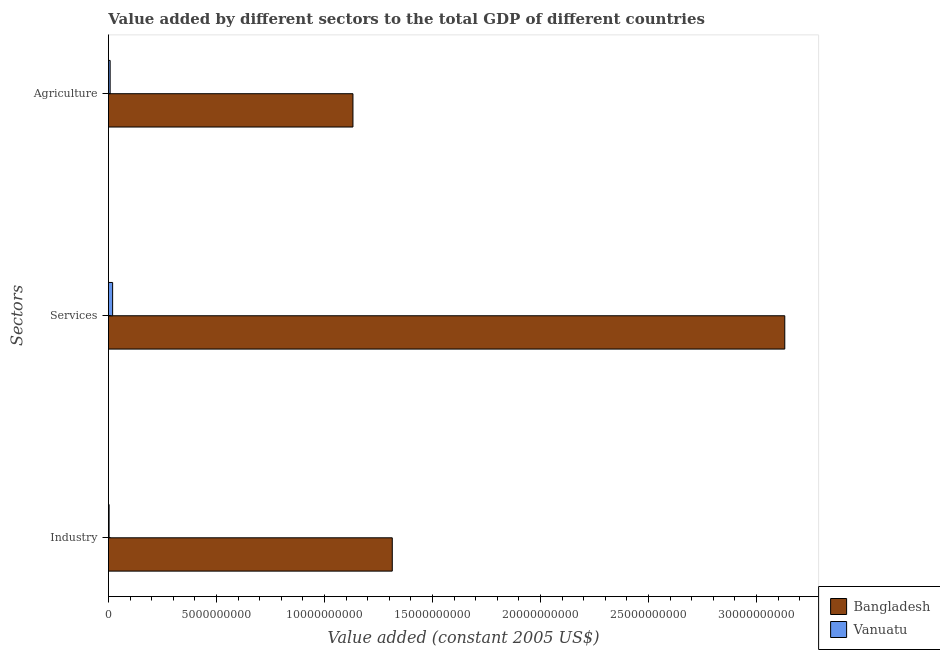How many different coloured bars are there?
Make the answer very short. 2. How many groups of bars are there?
Offer a terse response. 3. Are the number of bars per tick equal to the number of legend labels?
Offer a terse response. Yes. Are the number of bars on each tick of the Y-axis equal?
Ensure brevity in your answer.  Yes. How many bars are there on the 2nd tick from the bottom?
Your response must be concise. 2. What is the label of the 3rd group of bars from the top?
Make the answer very short. Industry. What is the value added by services in Bangladesh?
Provide a succinct answer. 3.13e+1. Across all countries, what is the maximum value added by agricultural sector?
Provide a succinct answer. 1.13e+1. Across all countries, what is the minimum value added by agricultural sector?
Give a very brief answer. 7.93e+07. In which country was the value added by services minimum?
Provide a short and direct response. Vanuatu. What is the total value added by industrial sector in the graph?
Offer a very short reply. 1.32e+1. What is the difference between the value added by industrial sector in Vanuatu and that in Bangladesh?
Offer a very short reply. -1.31e+1. What is the difference between the value added by services in Vanuatu and the value added by industrial sector in Bangladesh?
Provide a short and direct response. -1.29e+1. What is the average value added by industrial sector per country?
Offer a terse response. 6.59e+09. What is the difference between the value added by industrial sector and value added by agricultural sector in Vanuatu?
Your answer should be very brief. -4.77e+07. In how many countries, is the value added by agricultural sector greater than 22000000000 US$?
Your response must be concise. 0. What is the ratio of the value added by services in Vanuatu to that in Bangladesh?
Offer a terse response. 0.01. What is the difference between the highest and the second highest value added by industrial sector?
Make the answer very short. 1.31e+1. What is the difference between the highest and the lowest value added by services?
Make the answer very short. 3.11e+1. In how many countries, is the value added by services greater than the average value added by services taken over all countries?
Ensure brevity in your answer.  1. Is the sum of the value added by industrial sector in Bangladesh and Vanuatu greater than the maximum value added by services across all countries?
Keep it short and to the point. No. What does the 2nd bar from the bottom in Services represents?
Give a very brief answer. Vanuatu. How many bars are there?
Offer a very short reply. 6. What is the difference between two consecutive major ticks on the X-axis?
Give a very brief answer. 5.00e+09. Where does the legend appear in the graph?
Make the answer very short. Bottom right. How many legend labels are there?
Ensure brevity in your answer.  2. How are the legend labels stacked?
Your answer should be compact. Vertical. What is the title of the graph?
Your answer should be very brief. Value added by different sectors to the total GDP of different countries. What is the label or title of the X-axis?
Keep it short and to the point. Value added (constant 2005 US$). What is the label or title of the Y-axis?
Offer a terse response. Sectors. What is the Value added (constant 2005 US$) in Bangladesh in Industry?
Provide a short and direct response. 1.31e+1. What is the Value added (constant 2005 US$) of Vanuatu in Industry?
Your response must be concise. 3.15e+07. What is the Value added (constant 2005 US$) in Bangladesh in Services?
Provide a succinct answer. 3.13e+1. What is the Value added (constant 2005 US$) in Vanuatu in Services?
Your answer should be very brief. 1.94e+08. What is the Value added (constant 2005 US$) of Bangladesh in Agriculture?
Your answer should be compact. 1.13e+1. What is the Value added (constant 2005 US$) in Vanuatu in Agriculture?
Make the answer very short. 7.93e+07. Across all Sectors, what is the maximum Value added (constant 2005 US$) in Bangladesh?
Provide a short and direct response. 3.13e+1. Across all Sectors, what is the maximum Value added (constant 2005 US$) in Vanuatu?
Ensure brevity in your answer.  1.94e+08. Across all Sectors, what is the minimum Value added (constant 2005 US$) in Bangladesh?
Offer a terse response. 1.13e+1. Across all Sectors, what is the minimum Value added (constant 2005 US$) of Vanuatu?
Ensure brevity in your answer.  3.15e+07. What is the total Value added (constant 2005 US$) of Bangladesh in the graph?
Provide a succinct answer. 5.58e+1. What is the total Value added (constant 2005 US$) of Vanuatu in the graph?
Offer a very short reply. 3.05e+08. What is the difference between the Value added (constant 2005 US$) of Bangladesh in Industry and that in Services?
Your answer should be very brief. -1.82e+1. What is the difference between the Value added (constant 2005 US$) in Vanuatu in Industry and that in Services?
Keep it short and to the point. -1.63e+08. What is the difference between the Value added (constant 2005 US$) in Bangladesh in Industry and that in Agriculture?
Your answer should be very brief. 1.82e+09. What is the difference between the Value added (constant 2005 US$) in Vanuatu in Industry and that in Agriculture?
Give a very brief answer. -4.77e+07. What is the difference between the Value added (constant 2005 US$) in Bangladesh in Services and that in Agriculture?
Offer a very short reply. 2.00e+1. What is the difference between the Value added (constant 2005 US$) of Vanuatu in Services and that in Agriculture?
Provide a short and direct response. 1.15e+08. What is the difference between the Value added (constant 2005 US$) in Bangladesh in Industry and the Value added (constant 2005 US$) in Vanuatu in Services?
Your response must be concise. 1.29e+1. What is the difference between the Value added (constant 2005 US$) of Bangladesh in Industry and the Value added (constant 2005 US$) of Vanuatu in Agriculture?
Give a very brief answer. 1.31e+1. What is the difference between the Value added (constant 2005 US$) of Bangladesh in Services and the Value added (constant 2005 US$) of Vanuatu in Agriculture?
Ensure brevity in your answer.  3.12e+1. What is the average Value added (constant 2005 US$) in Bangladesh per Sectors?
Offer a very short reply. 1.86e+1. What is the average Value added (constant 2005 US$) in Vanuatu per Sectors?
Your answer should be very brief. 1.02e+08. What is the difference between the Value added (constant 2005 US$) in Bangladesh and Value added (constant 2005 US$) in Vanuatu in Industry?
Provide a short and direct response. 1.31e+1. What is the difference between the Value added (constant 2005 US$) of Bangladesh and Value added (constant 2005 US$) of Vanuatu in Services?
Offer a very short reply. 3.11e+1. What is the difference between the Value added (constant 2005 US$) of Bangladesh and Value added (constant 2005 US$) of Vanuatu in Agriculture?
Your response must be concise. 1.12e+1. What is the ratio of the Value added (constant 2005 US$) in Bangladesh in Industry to that in Services?
Your response must be concise. 0.42. What is the ratio of the Value added (constant 2005 US$) in Vanuatu in Industry to that in Services?
Offer a terse response. 0.16. What is the ratio of the Value added (constant 2005 US$) in Bangladesh in Industry to that in Agriculture?
Your response must be concise. 1.16. What is the ratio of the Value added (constant 2005 US$) of Vanuatu in Industry to that in Agriculture?
Provide a short and direct response. 0.4. What is the ratio of the Value added (constant 2005 US$) of Bangladesh in Services to that in Agriculture?
Offer a very short reply. 2.77. What is the ratio of the Value added (constant 2005 US$) in Vanuatu in Services to that in Agriculture?
Your answer should be very brief. 2.45. What is the difference between the highest and the second highest Value added (constant 2005 US$) of Bangladesh?
Make the answer very short. 1.82e+1. What is the difference between the highest and the second highest Value added (constant 2005 US$) in Vanuatu?
Your response must be concise. 1.15e+08. What is the difference between the highest and the lowest Value added (constant 2005 US$) in Bangladesh?
Make the answer very short. 2.00e+1. What is the difference between the highest and the lowest Value added (constant 2005 US$) in Vanuatu?
Give a very brief answer. 1.63e+08. 